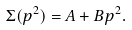Convert formula to latex. <formula><loc_0><loc_0><loc_500><loc_500>\Sigma ( p ^ { 2 } ) = A + B p ^ { 2 } .</formula> 